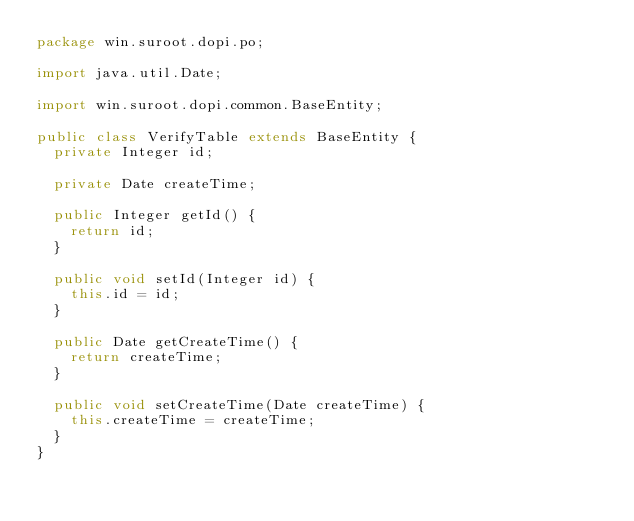<code> <loc_0><loc_0><loc_500><loc_500><_Java_>package win.suroot.dopi.po;

import java.util.Date;

import win.suroot.dopi.common.BaseEntity;

public class VerifyTable extends BaseEntity {
  private Integer id;

  private Date createTime;

  public Integer getId() {
    return id;
  }

  public void setId(Integer id) {
    this.id = id;
  }

  public Date getCreateTime() {
    return createTime;
  }

  public void setCreateTime(Date createTime) {
    this.createTime = createTime;
  }
}</code> 